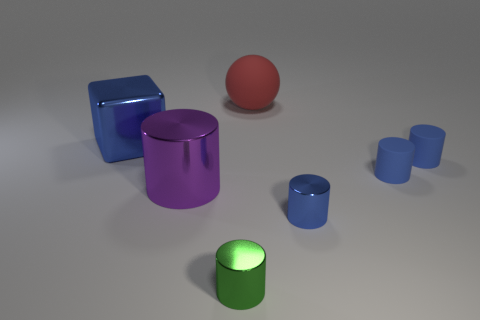Subtract all blue cylinders. How many were subtracted if there are1blue cylinders left? 2 Subtract all cyan blocks. How many blue cylinders are left? 3 Subtract all large purple cylinders. How many cylinders are left? 4 Subtract 3 cylinders. How many cylinders are left? 2 Subtract all green cylinders. How many cylinders are left? 4 Subtract all yellow cylinders. Subtract all green blocks. How many cylinders are left? 5 Add 1 rubber cylinders. How many objects exist? 8 Subtract all blocks. How many objects are left? 6 Subtract all large matte spheres. Subtract all large metal objects. How many objects are left? 4 Add 4 rubber objects. How many rubber objects are left? 7 